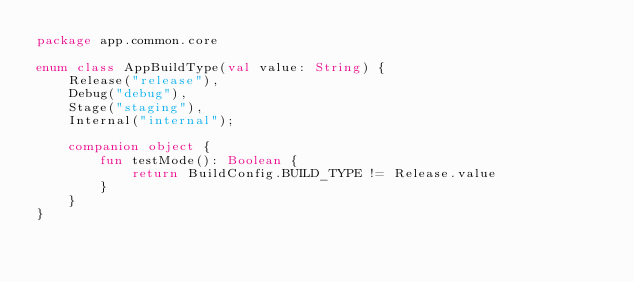<code> <loc_0><loc_0><loc_500><loc_500><_Kotlin_>package app.common.core

enum class AppBuildType(val value: String) {
    Release("release"),
    Debug("debug"),
    Stage("staging"),
    Internal("internal");

    companion object {
        fun testMode(): Boolean {
            return BuildConfig.BUILD_TYPE != Release.value
        }
    }
}

</code> 